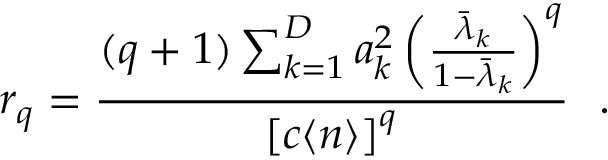<formula> <loc_0><loc_0><loc_500><loc_500>r _ { q } = \frac { ( q + 1 ) \sum _ { k = 1 } ^ { D } a _ { k } ^ { 2 } \left ( \frac { { { \bar { \lambda } } } _ { k } } { 1 - { { \bar { \lambda } } } _ { k } } \right ) ^ { q } } { \left [ c \langle n \rangle \right ] ^ { q } } \ \ .</formula> 